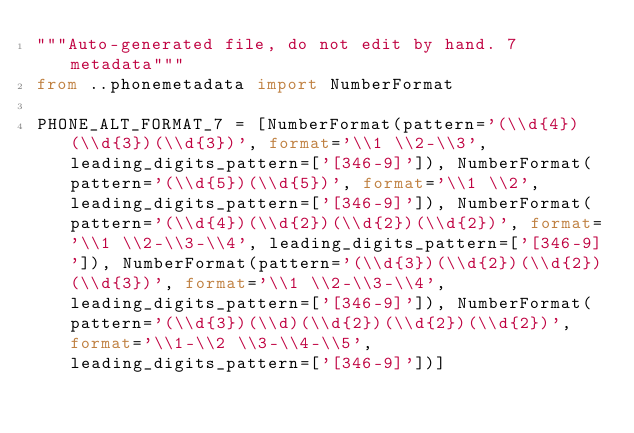<code> <loc_0><loc_0><loc_500><loc_500><_Python_>"""Auto-generated file, do not edit by hand. 7 metadata"""
from ..phonemetadata import NumberFormat

PHONE_ALT_FORMAT_7 = [NumberFormat(pattern='(\\d{4})(\\d{3})(\\d{3})', format='\\1 \\2-\\3', leading_digits_pattern=['[346-9]']), NumberFormat(pattern='(\\d{5})(\\d{5})', format='\\1 \\2', leading_digits_pattern=['[346-9]']), NumberFormat(pattern='(\\d{4})(\\d{2})(\\d{2})(\\d{2})', format='\\1 \\2-\\3-\\4', leading_digits_pattern=['[346-9]']), NumberFormat(pattern='(\\d{3})(\\d{2})(\\d{2})(\\d{3})', format='\\1 \\2-\\3-\\4', leading_digits_pattern=['[346-9]']), NumberFormat(pattern='(\\d{3})(\\d)(\\d{2})(\\d{2})(\\d{2})', format='\\1-\\2 \\3-\\4-\\5', leading_digits_pattern=['[346-9]'])]
</code> 